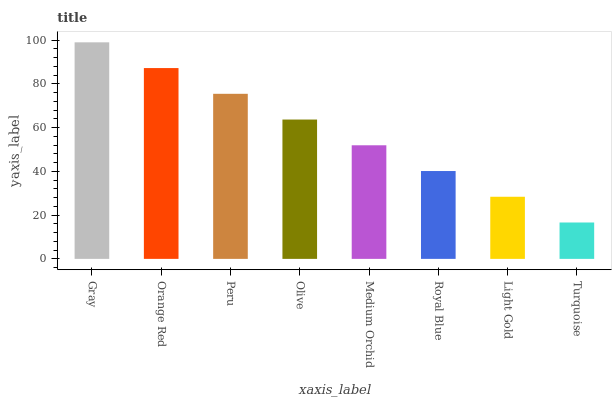Is Turquoise the minimum?
Answer yes or no. Yes. Is Gray the maximum?
Answer yes or no. Yes. Is Orange Red the minimum?
Answer yes or no. No. Is Orange Red the maximum?
Answer yes or no. No. Is Gray greater than Orange Red?
Answer yes or no. Yes. Is Orange Red less than Gray?
Answer yes or no. Yes. Is Orange Red greater than Gray?
Answer yes or no. No. Is Gray less than Orange Red?
Answer yes or no. No. Is Olive the high median?
Answer yes or no. Yes. Is Medium Orchid the low median?
Answer yes or no. Yes. Is Light Gold the high median?
Answer yes or no. No. Is Peru the low median?
Answer yes or no. No. 